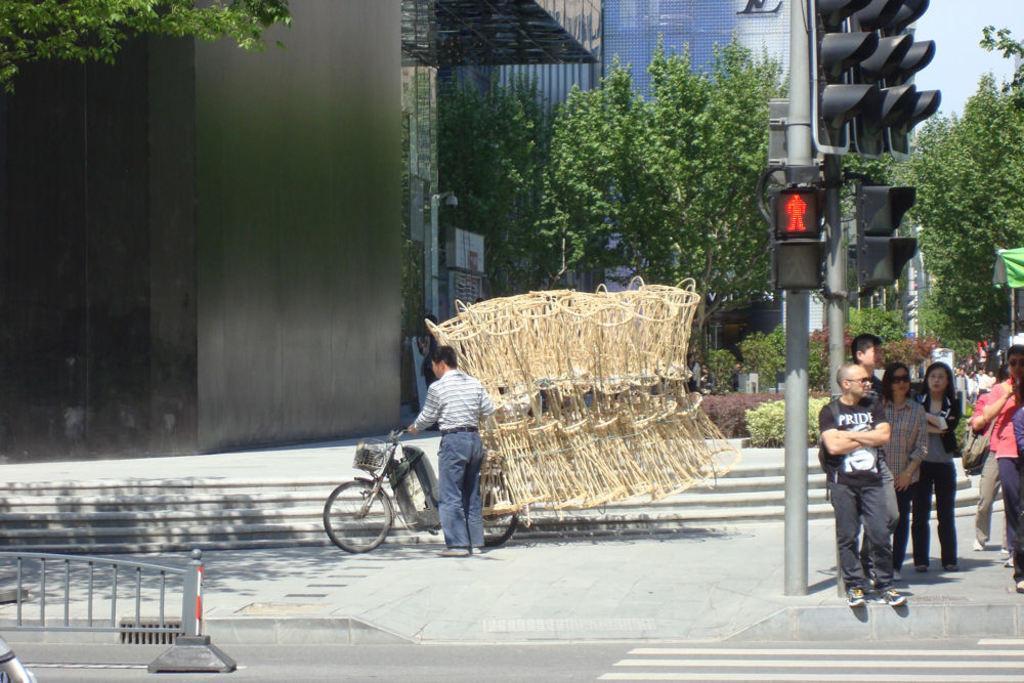How would you summarize this image in a sentence or two? In this picture we can see a pole and traffic lights, on the right there are some people standing, a person in the middle is holding a bicycle, in the background there are trees and buildings, we can see the sky at the right top of the picture, there are some stairs here. 